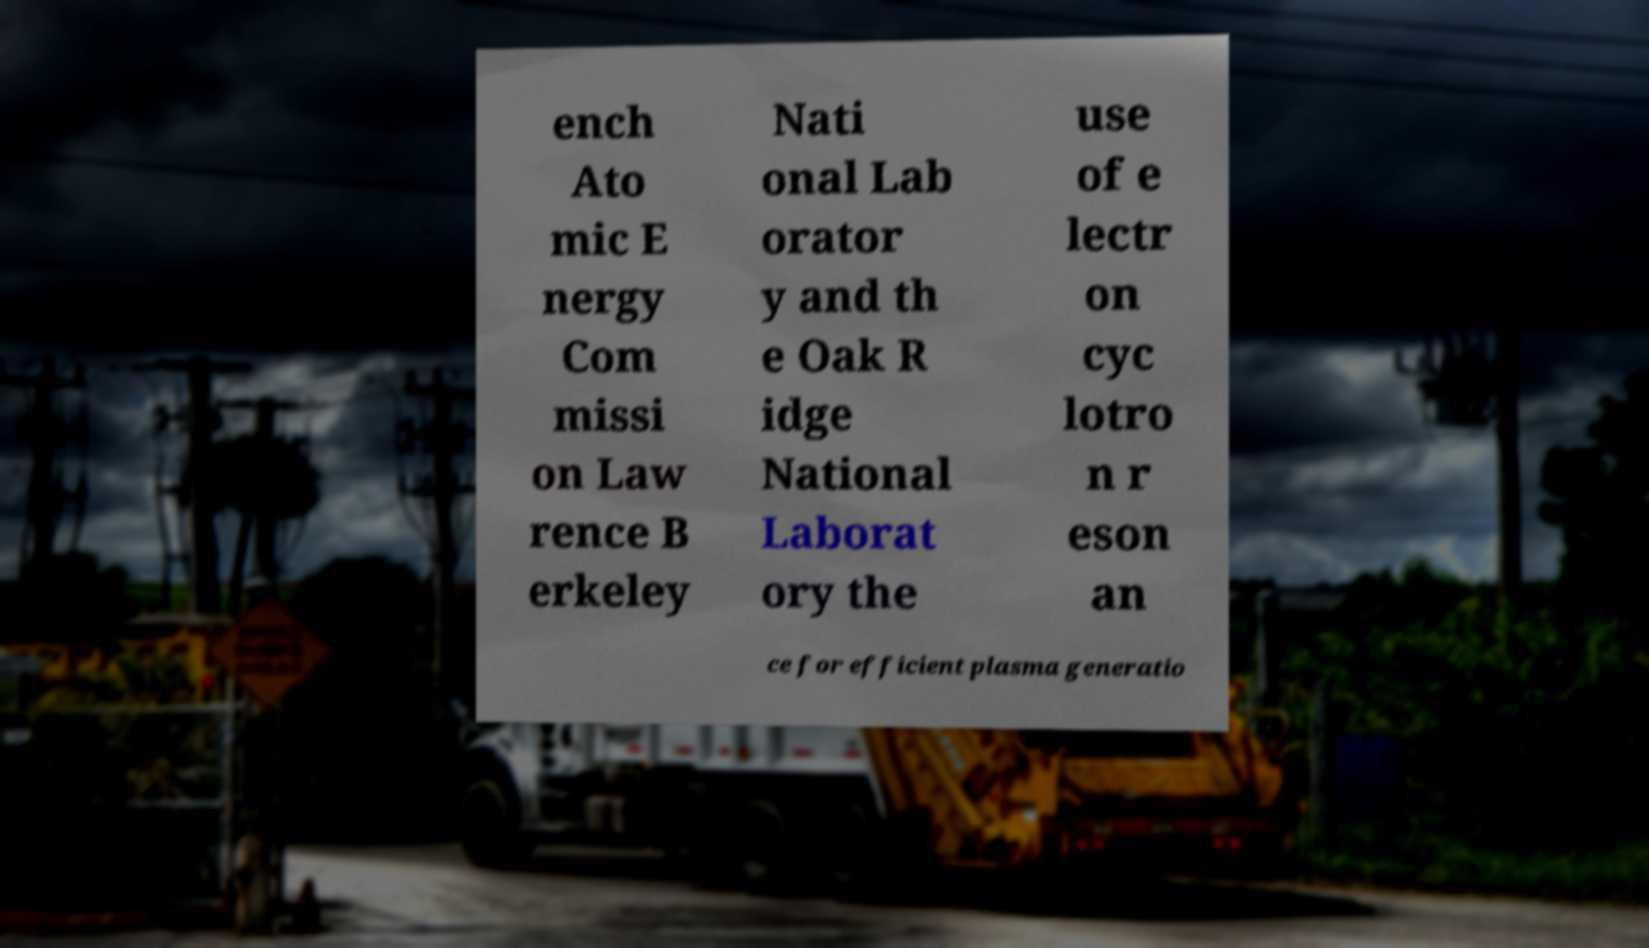Could you assist in decoding the text presented in this image and type it out clearly? ench Ato mic E nergy Com missi on Law rence B erkeley Nati onal Lab orator y and th e Oak R idge National Laborat ory the use of e lectr on cyc lotro n r eson an ce for efficient plasma generatio 